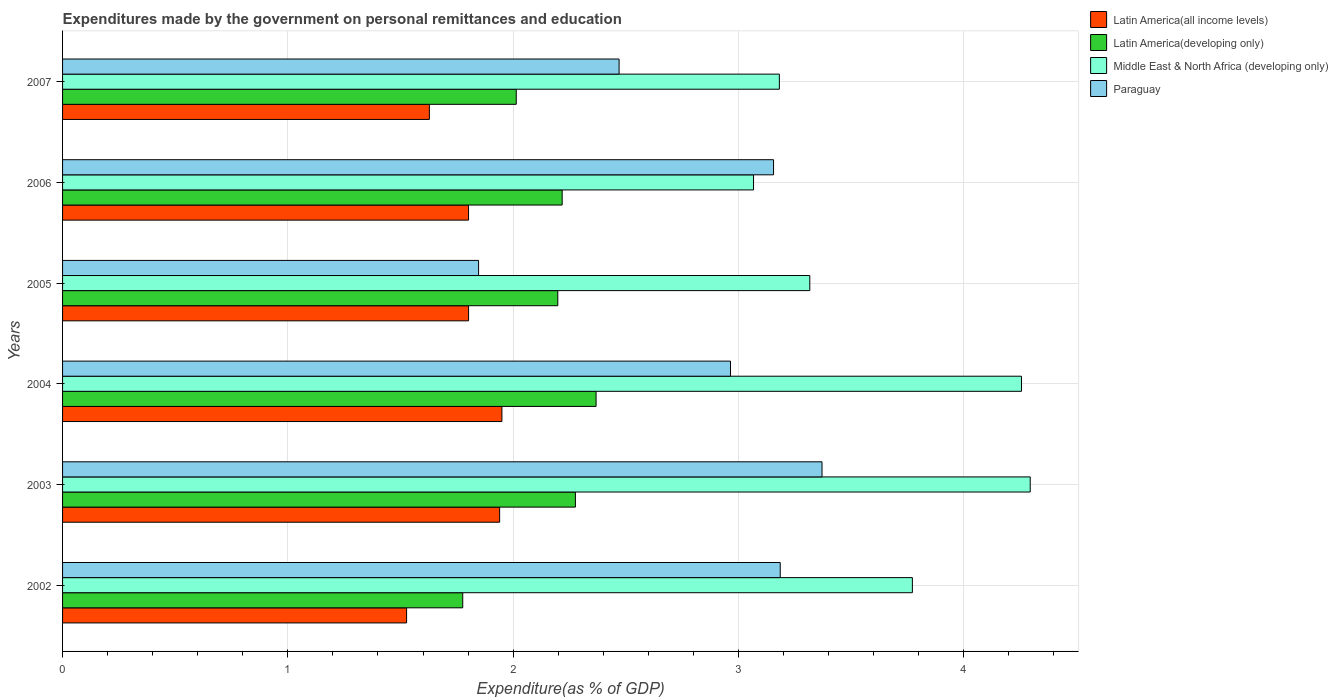Are the number of bars per tick equal to the number of legend labels?
Make the answer very short. Yes. Are the number of bars on each tick of the Y-axis equal?
Offer a very short reply. Yes. How many bars are there on the 1st tick from the top?
Provide a succinct answer. 4. What is the label of the 1st group of bars from the top?
Your answer should be very brief. 2007. What is the expenditures made by the government on personal remittances and education in Latin America(all income levels) in 2006?
Your answer should be compact. 1.8. Across all years, what is the maximum expenditures made by the government on personal remittances and education in Latin America(all income levels)?
Your answer should be very brief. 1.95. Across all years, what is the minimum expenditures made by the government on personal remittances and education in Middle East & North Africa (developing only)?
Make the answer very short. 3.07. In which year was the expenditures made by the government on personal remittances and education in Latin America(developing only) maximum?
Provide a succinct answer. 2004. What is the total expenditures made by the government on personal remittances and education in Middle East & North Africa (developing only) in the graph?
Your answer should be compact. 21.89. What is the difference between the expenditures made by the government on personal remittances and education in Middle East & North Africa (developing only) in 2005 and that in 2006?
Your response must be concise. 0.25. What is the difference between the expenditures made by the government on personal remittances and education in Paraguay in 2003 and the expenditures made by the government on personal remittances and education in Middle East & North Africa (developing only) in 2002?
Your answer should be very brief. -0.4. What is the average expenditures made by the government on personal remittances and education in Middle East & North Africa (developing only) per year?
Offer a very short reply. 3.65. In the year 2005, what is the difference between the expenditures made by the government on personal remittances and education in Latin America(all income levels) and expenditures made by the government on personal remittances and education in Latin America(developing only)?
Offer a terse response. -0.4. In how many years, is the expenditures made by the government on personal remittances and education in Latin America(developing only) greater than 0.4 %?
Keep it short and to the point. 6. What is the ratio of the expenditures made by the government on personal remittances and education in Paraguay in 2004 to that in 2005?
Provide a succinct answer. 1.61. Is the expenditures made by the government on personal remittances and education in Middle East & North Africa (developing only) in 2005 less than that in 2007?
Offer a very short reply. No. What is the difference between the highest and the second highest expenditures made by the government on personal remittances and education in Latin America(all income levels)?
Provide a succinct answer. 0.01. What is the difference between the highest and the lowest expenditures made by the government on personal remittances and education in Latin America(developing only)?
Offer a very short reply. 0.59. Is the sum of the expenditures made by the government on personal remittances and education in Latin America(all income levels) in 2003 and 2005 greater than the maximum expenditures made by the government on personal remittances and education in Middle East & North Africa (developing only) across all years?
Ensure brevity in your answer.  No. What does the 1st bar from the top in 2004 represents?
Provide a short and direct response. Paraguay. What does the 4th bar from the bottom in 2004 represents?
Keep it short and to the point. Paraguay. Is it the case that in every year, the sum of the expenditures made by the government on personal remittances and education in Middle East & North Africa (developing only) and expenditures made by the government on personal remittances and education in Latin America(developing only) is greater than the expenditures made by the government on personal remittances and education in Paraguay?
Provide a succinct answer. Yes. How many bars are there?
Your response must be concise. 24. Are all the bars in the graph horizontal?
Your answer should be compact. Yes. How many years are there in the graph?
Offer a terse response. 6. Are the values on the major ticks of X-axis written in scientific E-notation?
Offer a very short reply. No. Does the graph contain any zero values?
Your answer should be compact. No. Does the graph contain grids?
Your answer should be very brief. Yes. Where does the legend appear in the graph?
Provide a short and direct response. Top right. How many legend labels are there?
Provide a succinct answer. 4. How are the legend labels stacked?
Your response must be concise. Vertical. What is the title of the graph?
Offer a terse response. Expenditures made by the government on personal remittances and education. Does "Egypt, Arab Rep." appear as one of the legend labels in the graph?
Ensure brevity in your answer.  No. What is the label or title of the X-axis?
Keep it short and to the point. Expenditure(as % of GDP). What is the label or title of the Y-axis?
Ensure brevity in your answer.  Years. What is the Expenditure(as % of GDP) in Latin America(all income levels) in 2002?
Provide a succinct answer. 1.53. What is the Expenditure(as % of GDP) in Latin America(developing only) in 2002?
Your response must be concise. 1.78. What is the Expenditure(as % of GDP) in Middle East & North Africa (developing only) in 2002?
Offer a very short reply. 3.77. What is the Expenditure(as % of GDP) in Paraguay in 2002?
Offer a terse response. 3.19. What is the Expenditure(as % of GDP) of Latin America(all income levels) in 2003?
Your response must be concise. 1.94. What is the Expenditure(as % of GDP) in Latin America(developing only) in 2003?
Provide a short and direct response. 2.28. What is the Expenditure(as % of GDP) in Middle East & North Africa (developing only) in 2003?
Offer a very short reply. 4.3. What is the Expenditure(as % of GDP) in Paraguay in 2003?
Keep it short and to the point. 3.37. What is the Expenditure(as % of GDP) of Latin America(all income levels) in 2004?
Ensure brevity in your answer.  1.95. What is the Expenditure(as % of GDP) in Latin America(developing only) in 2004?
Give a very brief answer. 2.37. What is the Expenditure(as % of GDP) in Middle East & North Africa (developing only) in 2004?
Your response must be concise. 4.26. What is the Expenditure(as % of GDP) of Paraguay in 2004?
Your answer should be very brief. 2.96. What is the Expenditure(as % of GDP) in Latin America(all income levels) in 2005?
Your response must be concise. 1.8. What is the Expenditure(as % of GDP) of Latin America(developing only) in 2005?
Provide a short and direct response. 2.2. What is the Expenditure(as % of GDP) of Middle East & North Africa (developing only) in 2005?
Offer a very short reply. 3.32. What is the Expenditure(as % of GDP) in Paraguay in 2005?
Provide a short and direct response. 1.85. What is the Expenditure(as % of GDP) in Latin America(all income levels) in 2006?
Your answer should be very brief. 1.8. What is the Expenditure(as % of GDP) in Latin America(developing only) in 2006?
Provide a succinct answer. 2.22. What is the Expenditure(as % of GDP) in Middle East & North Africa (developing only) in 2006?
Ensure brevity in your answer.  3.07. What is the Expenditure(as % of GDP) in Paraguay in 2006?
Ensure brevity in your answer.  3.16. What is the Expenditure(as % of GDP) in Latin America(all income levels) in 2007?
Keep it short and to the point. 1.63. What is the Expenditure(as % of GDP) of Latin America(developing only) in 2007?
Provide a short and direct response. 2.01. What is the Expenditure(as % of GDP) in Middle East & North Africa (developing only) in 2007?
Give a very brief answer. 3.18. What is the Expenditure(as % of GDP) of Paraguay in 2007?
Your answer should be very brief. 2.47. Across all years, what is the maximum Expenditure(as % of GDP) in Latin America(all income levels)?
Offer a terse response. 1.95. Across all years, what is the maximum Expenditure(as % of GDP) in Latin America(developing only)?
Provide a short and direct response. 2.37. Across all years, what is the maximum Expenditure(as % of GDP) of Middle East & North Africa (developing only)?
Make the answer very short. 4.3. Across all years, what is the maximum Expenditure(as % of GDP) of Paraguay?
Offer a terse response. 3.37. Across all years, what is the minimum Expenditure(as % of GDP) in Latin America(all income levels)?
Keep it short and to the point. 1.53. Across all years, what is the minimum Expenditure(as % of GDP) in Latin America(developing only)?
Ensure brevity in your answer.  1.78. Across all years, what is the minimum Expenditure(as % of GDP) in Middle East & North Africa (developing only)?
Provide a short and direct response. 3.07. Across all years, what is the minimum Expenditure(as % of GDP) of Paraguay?
Provide a short and direct response. 1.85. What is the total Expenditure(as % of GDP) of Latin America(all income levels) in the graph?
Your answer should be compact. 10.65. What is the total Expenditure(as % of GDP) of Latin America(developing only) in the graph?
Your answer should be very brief. 12.85. What is the total Expenditure(as % of GDP) of Middle East & North Africa (developing only) in the graph?
Offer a terse response. 21.89. What is the total Expenditure(as % of GDP) of Paraguay in the graph?
Your answer should be compact. 17. What is the difference between the Expenditure(as % of GDP) in Latin America(all income levels) in 2002 and that in 2003?
Give a very brief answer. -0.41. What is the difference between the Expenditure(as % of GDP) of Latin America(developing only) in 2002 and that in 2003?
Provide a short and direct response. -0.5. What is the difference between the Expenditure(as % of GDP) of Middle East & North Africa (developing only) in 2002 and that in 2003?
Make the answer very short. -0.52. What is the difference between the Expenditure(as % of GDP) of Paraguay in 2002 and that in 2003?
Keep it short and to the point. -0.19. What is the difference between the Expenditure(as % of GDP) in Latin America(all income levels) in 2002 and that in 2004?
Provide a short and direct response. -0.42. What is the difference between the Expenditure(as % of GDP) in Latin America(developing only) in 2002 and that in 2004?
Ensure brevity in your answer.  -0.59. What is the difference between the Expenditure(as % of GDP) of Middle East & North Africa (developing only) in 2002 and that in 2004?
Your answer should be very brief. -0.48. What is the difference between the Expenditure(as % of GDP) in Paraguay in 2002 and that in 2004?
Ensure brevity in your answer.  0.22. What is the difference between the Expenditure(as % of GDP) in Latin America(all income levels) in 2002 and that in 2005?
Make the answer very short. -0.28. What is the difference between the Expenditure(as % of GDP) in Latin America(developing only) in 2002 and that in 2005?
Give a very brief answer. -0.42. What is the difference between the Expenditure(as % of GDP) in Middle East & North Africa (developing only) in 2002 and that in 2005?
Ensure brevity in your answer.  0.46. What is the difference between the Expenditure(as % of GDP) in Paraguay in 2002 and that in 2005?
Make the answer very short. 1.34. What is the difference between the Expenditure(as % of GDP) in Latin America(all income levels) in 2002 and that in 2006?
Offer a very short reply. -0.28. What is the difference between the Expenditure(as % of GDP) of Latin America(developing only) in 2002 and that in 2006?
Make the answer very short. -0.44. What is the difference between the Expenditure(as % of GDP) in Middle East & North Africa (developing only) in 2002 and that in 2006?
Provide a short and direct response. 0.71. What is the difference between the Expenditure(as % of GDP) of Paraguay in 2002 and that in 2006?
Provide a succinct answer. 0.03. What is the difference between the Expenditure(as % of GDP) of Latin America(all income levels) in 2002 and that in 2007?
Ensure brevity in your answer.  -0.1. What is the difference between the Expenditure(as % of GDP) in Latin America(developing only) in 2002 and that in 2007?
Provide a short and direct response. -0.24. What is the difference between the Expenditure(as % of GDP) of Middle East & North Africa (developing only) in 2002 and that in 2007?
Your answer should be compact. 0.59. What is the difference between the Expenditure(as % of GDP) of Paraguay in 2002 and that in 2007?
Your answer should be very brief. 0.72. What is the difference between the Expenditure(as % of GDP) of Latin America(all income levels) in 2003 and that in 2004?
Provide a short and direct response. -0.01. What is the difference between the Expenditure(as % of GDP) of Latin America(developing only) in 2003 and that in 2004?
Ensure brevity in your answer.  -0.09. What is the difference between the Expenditure(as % of GDP) of Middle East & North Africa (developing only) in 2003 and that in 2004?
Keep it short and to the point. 0.04. What is the difference between the Expenditure(as % of GDP) of Paraguay in 2003 and that in 2004?
Make the answer very short. 0.41. What is the difference between the Expenditure(as % of GDP) of Latin America(all income levels) in 2003 and that in 2005?
Offer a terse response. 0.14. What is the difference between the Expenditure(as % of GDP) in Latin America(developing only) in 2003 and that in 2005?
Offer a terse response. 0.08. What is the difference between the Expenditure(as % of GDP) of Middle East & North Africa (developing only) in 2003 and that in 2005?
Make the answer very short. 0.98. What is the difference between the Expenditure(as % of GDP) in Paraguay in 2003 and that in 2005?
Provide a short and direct response. 1.52. What is the difference between the Expenditure(as % of GDP) in Latin America(all income levels) in 2003 and that in 2006?
Provide a short and direct response. 0.14. What is the difference between the Expenditure(as % of GDP) in Latin America(developing only) in 2003 and that in 2006?
Provide a short and direct response. 0.06. What is the difference between the Expenditure(as % of GDP) of Middle East & North Africa (developing only) in 2003 and that in 2006?
Your answer should be very brief. 1.23. What is the difference between the Expenditure(as % of GDP) in Paraguay in 2003 and that in 2006?
Your answer should be compact. 0.22. What is the difference between the Expenditure(as % of GDP) of Latin America(all income levels) in 2003 and that in 2007?
Offer a very short reply. 0.31. What is the difference between the Expenditure(as % of GDP) of Latin America(developing only) in 2003 and that in 2007?
Make the answer very short. 0.26. What is the difference between the Expenditure(as % of GDP) in Middle East & North Africa (developing only) in 2003 and that in 2007?
Your response must be concise. 1.11. What is the difference between the Expenditure(as % of GDP) in Paraguay in 2003 and that in 2007?
Keep it short and to the point. 0.9. What is the difference between the Expenditure(as % of GDP) in Latin America(all income levels) in 2004 and that in 2005?
Provide a succinct answer. 0.15. What is the difference between the Expenditure(as % of GDP) in Latin America(developing only) in 2004 and that in 2005?
Offer a very short reply. 0.17. What is the difference between the Expenditure(as % of GDP) in Middle East & North Africa (developing only) in 2004 and that in 2005?
Offer a very short reply. 0.94. What is the difference between the Expenditure(as % of GDP) in Paraguay in 2004 and that in 2005?
Your answer should be compact. 1.12. What is the difference between the Expenditure(as % of GDP) in Latin America(all income levels) in 2004 and that in 2006?
Provide a succinct answer. 0.15. What is the difference between the Expenditure(as % of GDP) of Latin America(developing only) in 2004 and that in 2006?
Your answer should be compact. 0.15. What is the difference between the Expenditure(as % of GDP) in Middle East & North Africa (developing only) in 2004 and that in 2006?
Make the answer very short. 1.19. What is the difference between the Expenditure(as % of GDP) in Paraguay in 2004 and that in 2006?
Give a very brief answer. -0.19. What is the difference between the Expenditure(as % of GDP) of Latin America(all income levels) in 2004 and that in 2007?
Give a very brief answer. 0.32. What is the difference between the Expenditure(as % of GDP) in Latin America(developing only) in 2004 and that in 2007?
Your answer should be compact. 0.35. What is the difference between the Expenditure(as % of GDP) in Middle East & North Africa (developing only) in 2004 and that in 2007?
Offer a very short reply. 1.07. What is the difference between the Expenditure(as % of GDP) of Paraguay in 2004 and that in 2007?
Offer a terse response. 0.49. What is the difference between the Expenditure(as % of GDP) in Latin America(developing only) in 2005 and that in 2006?
Offer a very short reply. -0.02. What is the difference between the Expenditure(as % of GDP) in Middle East & North Africa (developing only) in 2005 and that in 2006?
Give a very brief answer. 0.25. What is the difference between the Expenditure(as % of GDP) in Paraguay in 2005 and that in 2006?
Make the answer very short. -1.31. What is the difference between the Expenditure(as % of GDP) in Latin America(all income levels) in 2005 and that in 2007?
Ensure brevity in your answer.  0.17. What is the difference between the Expenditure(as % of GDP) of Latin America(developing only) in 2005 and that in 2007?
Offer a very short reply. 0.18. What is the difference between the Expenditure(as % of GDP) in Middle East & North Africa (developing only) in 2005 and that in 2007?
Give a very brief answer. 0.14. What is the difference between the Expenditure(as % of GDP) of Paraguay in 2005 and that in 2007?
Make the answer very short. -0.62. What is the difference between the Expenditure(as % of GDP) of Latin America(all income levels) in 2006 and that in 2007?
Provide a short and direct response. 0.17. What is the difference between the Expenditure(as % of GDP) in Latin America(developing only) in 2006 and that in 2007?
Provide a short and direct response. 0.2. What is the difference between the Expenditure(as % of GDP) in Middle East & North Africa (developing only) in 2006 and that in 2007?
Offer a terse response. -0.11. What is the difference between the Expenditure(as % of GDP) of Paraguay in 2006 and that in 2007?
Your answer should be very brief. 0.69. What is the difference between the Expenditure(as % of GDP) in Latin America(all income levels) in 2002 and the Expenditure(as % of GDP) in Latin America(developing only) in 2003?
Make the answer very short. -0.75. What is the difference between the Expenditure(as % of GDP) of Latin America(all income levels) in 2002 and the Expenditure(as % of GDP) of Middle East & North Africa (developing only) in 2003?
Ensure brevity in your answer.  -2.77. What is the difference between the Expenditure(as % of GDP) of Latin America(all income levels) in 2002 and the Expenditure(as % of GDP) of Paraguay in 2003?
Your response must be concise. -1.84. What is the difference between the Expenditure(as % of GDP) in Latin America(developing only) in 2002 and the Expenditure(as % of GDP) in Middle East & North Africa (developing only) in 2003?
Provide a short and direct response. -2.52. What is the difference between the Expenditure(as % of GDP) in Latin America(developing only) in 2002 and the Expenditure(as % of GDP) in Paraguay in 2003?
Offer a very short reply. -1.59. What is the difference between the Expenditure(as % of GDP) of Middle East & North Africa (developing only) in 2002 and the Expenditure(as % of GDP) of Paraguay in 2003?
Ensure brevity in your answer.  0.4. What is the difference between the Expenditure(as % of GDP) of Latin America(all income levels) in 2002 and the Expenditure(as % of GDP) of Latin America(developing only) in 2004?
Offer a terse response. -0.84. What is the difference between the Expenditure(as % of GDP) of Latin America(all income levels) in 2002 and the Expenditure(as % of GDP) of Middle East & North Africa (developing only) in 2004?
Keep it short and to the point. -2.73. What is the difference between the Expenditure(as % of GDP) of Latin America(all income levels) in 2002 and the Expenditure(as % of GDP) of Paraguay in 2004?
Give a very brief answer. -1.44. What is the difference between the Expenditure(as % of GDP) in Latin America(developing only) in 2002 and the Expenditure(as % of GDP) in Middle East & North Africa (developing only) in 2004?
Provide a succinct answer. -2.48. What is the difference between the Expenditure(as % of GDP) in Latin America(developing only) in 2002 and the Expenditure(as % of GDP) in Paraguay in 2004?
Ensure brevity in your answer.  -1.19. What is the difference between the Expenditure(as % of GDP) of Middle East & North Africa (developing only) in 2002 and the Expenditure(as % of GDP) of Paraguay in 2004?
Keep it short and to the point. 0.81. What is the difference between the Expenditure(as % of GDP) in Latin America(all income levels) in 2002 and the Expenditure(as % of GDP) in Latin America(developing only) in 2005?
Offer a terse response. -0.67. What is the difference between the Expenditure(as % of GDP) of Latin America(all income levels) in 2002 and the Expenditure(as % of GDP) of Middle East & North Africa (developing only) in 2005?
Provide a succinct answer. -1.79. What is the difference between the Expenditure(as % of GDP) of Latin America(all income levels) in 2002 and the Expenditure(as % of GDP) of Paraguay in 2005?
Ensure brevity in your answer.  -0.32. What is the difference between the Expenditure(as % of GDP) of Latin America(developing only) in 2002 and the Expenditure(as % of GDP) of Middle East & North Africa (developing only) in 2005?
Your answer should be very brief. -1.54. What is the difference between the Expenditure(as % of GDP) in Latin America(developing only) in 2002 and the Expenditure(as % of GDP) in Paraguay in 2005?
Your answer should be very brief. -0.07. What is the difference between the Expenditure(as % of GDP) of Middle East & North Africa (developing only) in 2002 and the Expenditure(as % of GDP) of Paraguay in 2005?
Your response must be concise. 1.93. What is the difference between the Expenditure(as % of GDP) in Latin America(all income levels) in 2002 and the Expenditure(as % of GDP) in Latin America(developing only) in 2006?
Provide a succinct answer. -0.69. What is the difference between the Expenditure(as % of GDP) of Latin America(all income levels) in 2002 and the Expenditure(as % of GDP) of Middle East & North Africa (developing only) in 2006?
Give a very brief answer. -1.54. What is the difference between the Expenditure(as % of GDP) in Latin America(all income levels) in 2002 and the Expenditure(as % of GDP) in Paraguay in 2006?
Keep it short and to the point. -1.63. What is the difference between the Expenditure(as % of GDP) of Latin America(developing only) in 2002 and the Expenditure(as % of GDP) of Middle East & North Africa (developing only) in 2006?
Ensure brevity in your answer.  -1.29. What is the difference between the Expenditure(as % of GDP) of Latin America(developing only) in 2002 and the Expenditure(as % of GDP) of Paraguay in 2006?
Your answer should be compact. -1.38. What is the difference between the Expenditure(as % of GDP) of Middle East & North Africa (developing only) in 2002 and the Expenditure(as % of GDP) of Paraguay in 2006?
Keep it short and to the point. 0.62. What is the difference between the Expenditure(as % of GDP) of Latin America(all income levels) in 2002 and the Expenditure(as % of GDP) of Latin America(developing only) in 2007?
Ensure brevity in your answer.  -0.49. What is the difference between the Expenditure(as % of GDP) in Latin America(all income levels) in 2002 and the Expenditure(as % of GDP) in Middle East & North Africa (developing only) in 2007?
Keep it short and to the point. -1.65. What is the difference between the Expenditure(as % of GDP) of Latin America(all income levels) in 2002 and the Expenditure(as % of GDP) of Paraguay in 2007?
Make the answer very short. -0.94. What is the difference between the Expenditure(as % of GDP) in Latin America(developing only) in 2002 and the Expenditure(as % of GDP) in Middle East & North Africa (developing only) in 2007?
Ensure brevity in your answer.  -1.41. What is the difference between the Expenditure(as % of GDP) in Latin America(developing only) in 2002 and the Expenditure(as % of GDP) in Paraguay in 2007?
Provide a succinct answer. -0.69. What is the difference between the Expenditure(as % of GDP) of Middle East & North Africa (developing only) in 2002 and the Expenditure(as % of GDP) of Paraguay in 2007?
Offer a terse response. 1.3. What is the difference between the Expenditure(as % of GDP) in Latin America(all income levels) in 2003 and the Expenditure(as % of GDP) in Latin America(developing only) in 2004?
Your answer should be very brief. -0.43. What is the difference between the Expenditure(as % of GDP) of Latin America(all income levels) in 2003 and the Expenditure(as % of GDP) of Middle East & North Africa (developing only) in 2004?
Keep it short and to the point. -2.32. What is the difference between the Expenditure(as % of GDP) of Latin America(all income levels) in 2003 and the Expenditure(as % of GDP) of Paraguay in 2004?
Your answer should be compact. -1.02. What is the difference between the Expenditure(as % of GDP) of Latin America(developing only) in 2003 and the Expenditure(as % of GDP) of Middle East & North Africa (developing only) in 2004?
Offer a terse response. -1.98. What is the difference between the Expenditure(as % of GDP) of Latin America(developing only) in 2003 and the Expenditure(as % of GDP) of Paraguay in 2004?
Your answer should be compact. -0.69. What is the difference between the Expenditure(as % of GDP) in Middle East & North Africa (developing only) in 2003 and the Expenditure(as % of GDP) in Paraguay in 2004?
Offer a terse response. 1.33. What is the difference between the Expenditure(as % of GDP) of Latin America(all income levels) in 2003 and the Expenditure(as % of GDP) of Latin America(developing only) in 2005?
Ensure brevity in your answer.  -0.26. What is the difference between the Expenditure(as % of GDP) of Latin America(all income levels) in 2003 and the Expenditure(as % of GDP) of Middle East & North Africa (developing only) in 2005?
Offer a terse response. -1.38. What is the difference between the Expenditure(as % of GDP) in Latin America(all income levels) in 2003 and the Expenditure(as % of GDP) in Paraguay in 2005?
Your response must be concise. 0.09. What is the difference between the Expenditure(as % of GDP) in Latin America(developing only) in 2003 and the Expenditure(as % of GDP) in Middle East & North Africa (developing only) in 2005?
Your response must be concise. -1.04. What is the difference between the Expenditure(as % of GDP) in Latin America(developing only) in 2003 and the Expenditure(as % of GDP) in Paraguay in 2005?
Your response must be concise. 0.43. What is the difference between the Expenditure(as % of GDP) of Middle East & North Africa (developing only) in 2003 and the Expenditure(as % of GDP) of Paraguay in 2005?
Provide a succinct answer. 2.45. What is the difference between the Expenditure(as % of GDP) of Latin America(all income levels) in 2003 and the Expenditure(as % of GDP) of Latin America(developing only) in 2006?
Your answer should be very brief. -0.28. What is the difference between the Expenditure(as % of GDP) of Latin America(all income levels) in 2003 and the Expenditure(as % of GDP) of Middle East & North Africa (developing only) in 2006?
Provide a succinct answer. -1.13. What is the difference between the Expenditure(as % of GDP) of Latin America(all income levels) in 2003 and the Expenditure(as % of GDP) of Paraguay in 2006?
Keep it short and to the point. -1.22. What is the difference between the Expenditure(as % of GDP) of Latin America(developing only) in 2003 and the Expenditure(as % of GDP) of Middle East & North Africa (developing only) in 2006?
Your response must be concise. -0.79. What is the difference between the Expenditure(as % of GDP) in Latin America(developing only) in 2003 and the Expenditure(as % of GDP) in Paraguay in 2006?
Offer a very short reply. -0.88. What is the difference between the Expenditure(as % of GDP) in Middle East & North Africa (developing only) in 2003 and the Expenditure(as % of GDP) in Paraguay in 2006?
Make the answer very short. 1.14. What is the difference between the Expenditure(as % of GDP) of Latin America(all income levels) in 2003 and the Expenditure(as % of GDP) of Latin America(developing only) in 2007?
Your response must be concise. -0.07. What is the difference between the Expenditure(as % of GDP) in Latin America(all income levels) in 2003 and the Expenditure(as % of GDP) in Middle East & North Africa (developing only) in 2007?
Ensure brevity in your answer.  -1.24. What is the difference between the Expenditure(as % of GDP) of Latin America(all income levels) in 2003 and the Expenditure(as % of GDP) of Paraguay in 2007?
Provide a short and direct response. -0.53. What is the difference between the Expenditure(as % of GDP) of Latin America(developing only) in 2003 and the Expenditure(as % of GDP) of Middle East & North Africa (developing only) in 2007?
Your answer should be very brief. -0.91. What is the difference between the Expenditure(as % of GDP) in Latin America(developing only) in 2003 and the Expenditure(as % of GDP) in Paraguay in 2007?
Ensure brevity in your answer.  -0.19. What is the difference between the Expenditure(as % of GDP) of Middle East & North Africa (developing only) in 2003 and the Expenditure(as % of GDP) of Paraguay in 2007?
Keep it short and to the point. 1.82. What is the difference between the Expenditure(as % of GDP) of Latin America(all income levels) in 2004 and the Expenditure(as % of GDP) of Latin America(developing only) in 2005?
Provide a short and direct response. -0.25. What is the difference between the Expenditure(as % of GDP) of Latin America(all income levels) in 2004 and the Expenditure(as % of GDP) of Middle East & North Africa (developing only) in 2005?
Offer a very short reply. -1.37. What is the difference between the Expenditure(as % of GDP) of Latin America(all income levels) in 2004 and the Expenditure(as % of GDP) of Paraguay in 2005?
Offer a very short reply. 0.1. What is the difference between the Expenditure(as % of GDP) of Latin America(developing only) in 2004 and the Expenditure(as % of GDP) of Middle East & North Africa (developing only) in 2005?
Ensure brevity in your answer.  -0.95. What is the difference between the Expenditure(as % of GDP) of Latin America(developing only) in 2004 and the Expenditure(as % of GDP) of Paraguay in 2005?
Offer a very short reply. 0.52. What is the difference between the Expenditure(as % of GDP) in Middle East & North Africa (developing only) in 2004 and the Expenditure(as % of GDP) in Paraguay in 2005?
Provide a succinct answer. 2.41. What is the difference between the Expenditure(as % of GDP) of Latin America(all income levels) in 2004 and the Expenditure(as % of GDP) of Latin America(developing only) in 2006?
Provide a succinct answer. -0.27. What is the difference between the Expenditure(as % of GDP) of Latin America(all income levels) in 2004 and the Expenditure(as % of GDP) of Middle East & North Africa (developing only) in 2006?
Your response must be concise. -1.12. What is the difference between the Expenditure(as % of GDP) in Latin America(all income levels) in 2004 and the Expenditure(as % of GDP) in Paraguay in 2006?
Your answer should be compact. -1.21. What is the difference between the Expenditure(as % of GDP) in Latin America(developing only) in 2004 and the Expenditure(as % of GDP) in Middle East & North Africa (developing only) in 2006?
Provide a succinct answer. -0.7. What is the difference between the Expenditure(as % of GDP) in Latin America(developing only) in 2004 and the Expenditure(as % of GDP) in Paraguay in 2006?
Make the answer very short. -0.79. What is the difference between the Expenditure(as % of GDP) in Middle East & North Africa (developing only) in 2004 and the Expenditure(as % of GDP) in Paraguay in 2006?
Ensure brevity in your answer.  1.1. What is the difference between the Expenditure(as % of GDP) of Latin America(all income levels) in 2004 and the Expenditure(as % of GDP) of Latin America(developing only) in 2007?
Make the answer very short. -0.06. What is the difference between the Expenditure(as % of GDP) in Latin America(all income levels) in 2004 and the Expenditure(as % of GDP) in Middle East & North Africa (developing only) in 2007?
Keep it short and to the point. -1.23. What is the difference between the Expenditure(as % of GDP) of Latin America(all income levels) in 2004 and the Expenditure(as % of GDP) of Paraguay in 2007?
Your answer should be very brief. -0.52. What is the difference between the Expenditure(as % of GDP) of Latin America(developing only) in 2004 and the Expenditure(as % of GDP) of Middle East & North Africa (developing only) in 2007?
Your response must be concise. -0.81. What is the difference between the Expenditure(as % of GDP) in Latin America(developing only) in 2004 and the Expenditure(as % of GDP) in Paraguay in 2007?
Ensure brevity in your answer.  -0.1. What is the difference between the Expenditure(as % of GDP) of Middle East & North Africa (developing only) in 2004 and the Expenditure(as % of GDP) of Paraguay in 2007?
Ensure brevity in your answer.  1.79. What is the difference between the Expenditure(as % of GDP) of Latin America(all income levels) in 2005 and the Expenditure(as % of GDP) of Latin America(developing only) in 2006?
Offer a very short reply. -0.42. What is the difference between the Expenditure(as % of GDP) in Latin America(all income levels) in 2005 and the Expenditure(as % of GDP) in Middle East & North Africa (developing only) in 2006?
Offer a terse response. -1.26. What is the difference between the Expenditure(as % of GDP) of Latin America(all income levels) in 2005 and the Expenditure(as % of GDP) of Paraguay in 2006?
Your response must be concise. -1.35. What is the difference between the Expenditure(as % of GDP) in Latin America(developing only) in 2005 and the Expenditure(as % of GDP) in Middle East & North Africa (developing only) in 2006?
Provide a short and direct response. -0.87. What is the difference between the Expenditure(as % of GDP) in Latin America(developing only) in 2005 and the Expenditure(as % of GDP) in Paraguay in 2006?
Ensure brevity in your answer.  -0.96. What is the difference between the Expenditure(as % of GDP) of Middle East & North Africa (developing only) in 2005 and the Expenditure(as % of GDP) of Paraguay in 2006?
Your answer should be compact. 0.16. What is the difference between the Expenditure(as % of GDP) of Latin America(all income levels) in 2005 and the Expenditure(as % of GDP) of Latin America(developing only) in 2007?
Make the answer very short. -0.21. What is the difference between the Expenditure(as % of GDP) of Latin America(all income levels) in 2005 and the Expenditure(as % of GDP) of Middle East & North Africa (developing only) in 2007?
Provide a succinct answer. -1.38. What is the difference between the Expenditure(as % of GDP) in Latin America(all income levels) in 2005 and the Expenditure(as % of GDP) in Paraguay in 2007?
Make the answer very short. -0.67. What is the difference between the Expenditure(as % of GDP) of Latin America(developing only) in 2005 and the Expenditure(as % of GDP) of Middle East & North Africa (developing only) in 2007?
Ensure brevity in your answer.  -0.98. What is the difference between the Expenditure(as % of GDP) of Latin America(developing only) in 2005 and the Expenditure(as % of GDP) of Paraguay in 2007?
Give a very brief answer. -0.27. What is the difference between the Expenditure(as % of GDP) in Middle East & North Africa (developing only) in 2005 and the Expenditure(as % of GDP) in Paraguay in 2007?
Offer a very short reply. 0.85. What is the difference between the Expenditure(as % of GDP) of Latin America(all income levels) in 2006 and the Expenditure(as % of GDP) of Latin America(developing only) in 2007?
Ensure brevity in your answer.  -0.21. What is the difference between the Expenditure(as % of GDP) in Latin America(all income levels) in 2006 and the Expenditure(as % of GDP) in Middle East & North Africa (developing only) in 2007?
Offer a very short reply. -1.38. What is the difference between the Expenditure(as % of GDP) in Latin America(all income levels) in 2006 and the Expenditure(as % of GDP) in Paraguay in 2007?
Your response must be concise. -0.67. What is the difference between the Expenditure(as % of GDP) in Latin America(developing only) in 2006 and the Expenditure(as % of GDP) in Middle East & North Africa (developing only) in 2007?
Ensure brevity in your answer.  -0.96. What is the difference between the Expenditure(as % of GDP) in Latin America(developing only) in 2006 and the Expenditure(as % of GDP) in Paraguay in 2007?
Give a very brief answer. -0.25. What is the difference between the Expenditure(as % of GDP) of Middle East & North Africa (developing only) in 2006 and the Expenditure(as % of GDP) of Paraguay in 2007?
Offer a terse response. 0.6. What is the average Expenditure(as % of GDP) in Latin America(all income levels) per year?
Give a very brief answer. 1.77. What is the average Expenditure(as % of GDP) of Latin America(developing only) per year?
Provide a short and direct response. 2.14. What is the average Expenditure(as % of GDP) in Middle East & North Africa (developing only) per year?
Your response must be concise. 3.65. What is the average Expenditure(as % of GDP) in Paraguay per year?
Your response must be concise. 2.83. In the year 2002, what is the difference between the Expenditure(as % of GDP) in Latin America(all income levels) and Expenditure(as % of GDP) in Latin America(developing only)?
Offer a very short reply. -0.25. In the year 2002, what is the difference between the Expenditure(as % of GDP) in Latin America(all income levels) and Expenditure(as % of GDP) in Middle East & North Africa (developing only)?
Make the answer very short. -2.25. In the year 2002, what is the difference between the Expenditure(as % of GDP) of Latin America(all income levels) and Expenditure(as % of GDP) of Paraguay?
Provide a short and direct response. -1.66. In the year 2002, what is the difference between the Expenditure(as % of GDP) of Latin America(developing only) and Expenditure(as % of GDP) of Middle East & North Africa (developing only)?
Give a very brief answer. -2. In the year 2002, what is the difference between the Expenditure(as % of GDP) in Latin America(developing only) and Expenditure(as % of GDP) in Paraguay?
Ensure brevity in your answer.  -1.41. In the year 2002, what is the difference between the Expenditure(as % of GDP) of Middle East & North Africa (developing only) and Expenditure(as % of GDP) of Paraguay?
Provide a short and direct response. 0.59. In the year 2003, what is the difference between the Expenditure(as % of GDP) of Latin America(all income levels) and Expenditure(as % of GDP) of Latin America(developing only)?
Make the answer very short. -0.34. In the year 2003, what is the difference between the Expenditure(as % of GDP) of Latin America(all income levels) and Expenditure(as % of GDP) of Middle East & North Africa (developing only)?
Your answer should be compact. -2.36. In the year 2003, what is the difference between the Expenditure(as % of GDP) of Latin America(all income levels) and Expenditure(as % of GDP) of Paraguay?
Your answer should be very brief. -1.43. In the year 2003, what is the difference between the Expenditure(as % of GDP) in Latin America(developing only) and Expenditure(as % of GDP) in Middle East & North Africa (developing only)?
Keep it short and to the point. -2.02. In the year 2003, what is the difference between the Expenditure(as % of GDP) of Latin America(developing only) and Expenditure(as % of GDP) of Paraguay?
Give a very brief answer. -1.09. In the year 2003, what is the difference between the Expenditure(as % of GDP) in Middle East & North Africa (developing only) and Expenditure(as % of GDP) in Paraguay?
Offer a terse response. 0.92. In the year 2004, what is the difference between the Expenditure(as % of GDP) of Latin America(all income levels) and Expenditure(as % of GDP) of Latin America(developing only)?
Your answer should be very brief. -0.42. In the year 2004, what is the difference between the Expenditure(as % of GDP) in Latin America(all income levels) and Expenditure(as % of GDP) in Middle East & North Africa (developing only)?
Offer a terse response. -2.31. In the year 2004, what is the difference between the Expenditure(as % of GDP) of Latin America(all income levels) and Expenditure(as % of GDP) of Paraguay?
Ensure brevity in your answer.  -1.01. In the year 2004, what is the difference between the Expenditure(as % of GDP) of Latin America(developing only) and Expenditure(as % of GDP) of Middle East & North Africa (developing only)?
Your answer should be very brief. -1.89. In the year 2004, what is the difference between the Expenditure(as % of GDP) of Latin America(developing only) and Expenditure(as % of GDP) of Paraguay?
Offer a terse response. -0.6. In the year 2004, what is the difference between the Expenditure(as % of GDP) of Middle East & North Africa (developing only) and Expenditure(as % of GDP) of Paraguay?
Offer a very short reply. 1.29. In the year 2005, what is the difference between the Expenditure(as % of GDP) of Latin America(all income levels) and Expenditure(as % of GDP) of Latin America(developing only)?
Your answer should be compact. -0.4. In the year 2005, what is the difference between the Expenditure(as % of GDP) of Latin America(all income levels) and Expenditure(as % of GDP) of Middle East & North Africa (developing only)?
Provide a succinct answer. -1.51. In the year 2005, what is the difference between the Expenditure(as % of GDP) of Latin America(all income levels) and Expenditure(as % of GDP) of Paraguay?
Offer a terse response. -0.04. In the year 2005, what is the difference between the Expenditure(as % of GDP) of Latin America(developing only) and Expenditure(as % of GDP) of Middle East & North Africa (developing only)?
Offer a very short reply. -1.12. In the year 2005, what is the difference between the Expenditure(as % of GDP) of Latin America(developing only) and Expenditure(as % of GDP) of Paraguay?
Make the answer very short. 0.35. In the year 2005, what is the difference between the Expenditure(as % of GDP) in Middle East & North Africa (developing only) and Expenditure(as % of GDP) in Paraguay?
Your response must be concise. 1.47. In the year 2006, what is the difference between the Expenditure(as % of GDP) of Latin America(all income levels) and Expenditure(as % of GDP) of Latin America(developing only)?
Ensure brevity in your answer.  -0.42. In the year 2006, what is the difference between the Expenditure(as % of GDP) in Latin America(all income levels) and Expenditure(as % of GDP) in Middle East & North Africa (developing only)?
Ensure brevity in your answer.  -1.26. In the year 2006, what is the difference between the Expenditure(as % of GDP) of Latin America(all income levels) and Expenditure(as % of GDP) of Paraguay?
Give a very brief answer. -1.35. In the year 2006, what is the difference between the Expenditure(as % of GDP) of Latin America(developing only) and Expenditure(as % of GDP) of Middle East & North Africa (developing only)?
Your answer should be compact. -0.85. In the year 2006, what is the difference between the Expenditure(as % of GDP) in Latin America(developing only) and Expenditure(as % of GDP) in Paraguay?
Give a very brief answer. -0.94. In the year 2006, what is the difference between the Expenditure(as % of GDP) in Middle East & North Africa (developing only) and Expenditure(as % of GDP) in Paraguay?
Your response must be concise. -0.09. In the year 2007, what is the difference between the Expenditure(as % of GDP) of Latin America(all income levels) and Expenditure(as % of GDP) of Latin America(developing only)?
Your response must be concise. -0.39. In the year 2007, what is the difference between the Expenditure(as % of GDP) in Latin America(all income levels) and Expenditure(as % of GDP) in Middle East & North Africa (developing only)?
Keep it short and to the point. -1.55. In the year 2007, what is the difference between the Expenditure(as % of GDP) in Latin America(all income levels) and Expenditure(as % of GDP) in Paraguay?
Offer a terse response. -0.84. In the year 2007, what is the difference between the Expenditure(as % of GDP) in Latin America(developing only) and Expenditure(as % of GDP) in Middle East & North Africa (developing only)?
Your answer should be compact. -1.17. In the year 2007, what is the difference between the Expenditure(as % of GDP) of Latin America(developing only) and Expenditure(as % of GDP) of Paraguay?
Offer a terse response. -0.46. In the year 2007, what is the difference between the Expenditure(as % of GDP) of Middle East & North Africa (developing only) and Expenditure(as % of GDP) of Paraguay?
Ensure brevity in your answer.  0.71. What is the ratio of the Expenditure(as % of GDP) of Latin America(all income levels) in 2002 to that in 2003?
Offer a terse response. 0.79. What is the ratio of the Expenditure(as % of GDP) of Latin America(developing only) in 2002 to that in 2003?
Offer a terse response. 0.78. What is the ratio of the Expenditure(as % of GDP) in Middle East & North Africa (developing only) in 2002 to that in 2003?
Your response must be concise. 0.88. What is the ratio of the Expenditure(as % of GDP) in Paraguay in 2002 to that in 2003?
Offer a very short reply. 0.94. What is the ratio of the Expenditure(as % of GDP) in Latin America(all income levels) in 2002 to that in 2004?
Ensure brevity in your answer.  0.78. What is the ratio of the Expenditure(as % of GDP) of Middle East & North Africa (developing only) in 2002 to that in 2004?
Offer a very short reply. 0.89. What is the ratio of the Expenditure(as % of GDP) of Paraguay in 2002 to that in 2004?
Ensure brevity in your answer.  1.07. What is the ratio of the Expenditure(as % of GDP) in Latin America(all income levels) in 2002 to that in 2005?
Keep it short and to the point. 0.85. What is the ratio of the Expenditure(as % of GDP) in Latin America(developing only) in 2002 to that in 2005?
Offer a very short reply. 0.81. What is the ratio of the Expenditure(as % of GDP) in Middle East & North Africa (developing only) in 2002 to that in 2005?
Give a very brief answer. 1.14. What is the ratio of the Expenditure(as % of GDP) of Paraguay in 2002 to that in 2005?
Make the answer very short. 1.73. What is the ratio of the Expenditure(as % of GDP) in Latin America(all income levels) in 2002 to that in 2006?
Provide a succinct answer. 0.85. What is the ratio of the Expenditure(as % of GDP) in Latin America(developing only) in 2002 to that in 2006?
Give a very brief answer. 0.8. What is the ratio of the Expenditure(as % of GDP) of Middle East & North Africa (developing only) in 2002 to that in 2006?
Keep it short and to the point. 1.23. What is the ratio of the Expenditure(as % of GDP) of Paraguay in 2002 to that in 2006?
Your response must be concise. 1.01. What is the ratio of the Expenditure(as % of GDP) in Latin America(all income levels) in 2002 to that in 2007?
Provide a short and direct response. 0.94. What is the ratio of the Expenditure(as % of GDP) in Latin America(developing only) in 2002 to that in 2007?
Provide a short and direct response. 0.88. What is the ratio of the Expenditure(as % of GDP) of Middle East & North Africa (developing only) in 2002 to that in 2007?
Offer a terse response. 1.19. What is the ratio of the Expenditure(as % of GDP) of Paraguay in 2002 to that in 2007?
Make the answer very short. 1.29. What is the ratio of the Expenditure(as % of GDP) in Latin America(developing only) in 2003 to that in 2004?
Make the answer very short. 0.96. What is the ratio of the Expenditure(as % of GDP) in Middle East & North Africa (developing only) in 2003 to that in 2004?
Your answer should be compact. 1.01. What is the ratio of the Expenditure(as % of GDP) of Paraguay in 2003 to that in 2004?
Your answer should be compact. 1.14. What is the ratio of the Expenditure(as % of GDP) of Latin America(all income levels) in 2003 to that in 2005?
Ensure brevity in your answer.  1.08. What is the ratio of the Expenditure(as % of GDP) of Latin America(developing only) in 2003 to that in 2005?
Ensure brevity in your answer.  1.04. What is the ratio of the Expenditure(as % of GDP) in Middle East & North Africa (developing only) in 2003 to that in 2005?
Provide a short and direct response. 1.29. What is the ratio of the Expenditure(as % of GDP) of Paraguay in 2003 to that in 2005?
Offer a very short reply. 1.83. What is the ratio of the Expenditure(as % of GDP) of Latin America(all income levels) in 2003 to that in 2006?
Your response must be concise. 1.08. What is the ratio of the Expenditure(as % of GDP) of Latin America(developing only) in 2003 to that in 2006?
Your answer should be very brief. 1.03. What is the ratio of the Expenditure(as % of GDP) in Middle East & North Africa (developing only) in 2003 to that in 2006?
Ensure brevity in your answer.  1.4. What is the ratio of the Expenditure(as % of GDP) in Paraguay in 2003 to that in 2006?
Your answer should be compact. 1.07. What is the ratio of the Expenditure(as % of GDP) of Latin America(all income levels) in 2003 to that in 2007?
Make the answer very short. 1.19. What is the ratio of the Expenditure(as % of GDP) of Latin America(developing only) in 2003 to that in 2007?
Provide a short and direct response. 1.13. What is the ratio of the Expenditure(as % of GDP) in Middle East & North Africa (developing only) in 2003 to that in 2007?
Provide a short and direct response. 1.35. What is the ratio of the Expenditure(as % of GDP) in Paraguay in 2003 to that in 2007?
Provide a short and direct response. 1.36. What is the ratio of the Expenditure(as % of GDP) of Latin America(all income levels) in 2004 to that in 2005?
Provide a succinct answer. 1.08. What is the ratio of the Expenditure(as % of GDP) in Latin America(developing only) in 2004 to that in 2005?
Ensure brevity in your answer.  1.08. What is the ratio of the Expenditure(as % of GDP) in Middle East & North Africa (developing only) in 2004 to that in 2005?
Provide a short and direct response. 1.28. What is the ratio of the Expenditure(as % of GDP) in Paraguay in 2004 to that in 2005?
Make the answer very short. 1.61. What is the ratio of the Expenditure(as % of GDP) in Latin America(all income levels) in 2004 to that in 2006?
Ensure brevity in your answer.  1.08. What is the ratio of the Expenditure(as % of GDP) in Latin America(developing only) in 2004 to that in 2006?
Offer a terse response. 1.07. What is the ratio of the Expenditure(as % of GDP) in Middle East & North Africa (developing only) in 2004 to that in 2006?
Keep it short and to the point. 1.39. What is the ratio of the Expenditure(as % of GDP) in Paraguay in 2004 to that in 2006?
Provide a short and direct response. 0.94. What is the ratio of the Expenditure(as % of GDP) of Latin America(all income levels) in 2004 to that in 2007?
Your answer should be very brief. 1.2. What is the ratio of the Expenditure(as % of GDP) in Latin America(developing only) in 2004 to that in 2007?
Keep it short and to the point. 1.18. What is the ratio of the Expenditure(as % of GDP) of Middle East & North Africa (developing only) in 2004 to that in 2007?
Give a very brief answer. 1.34. What is the ratio of the Expenditure(as % of GDP) in Paraguay in 2004 to that in 2007?
Keep it short and to the point. 1.2. What is the ratio of the Expenditure(as % of GDP) of Latin America(all income levels) in 2005 to that in 2006?
Provide a short and direct response. 1. What is the ratio of the Expenditure(as % of GDP) of Middle East & North Africa (developing only) in 2005 to that in 2006?
Ensure brevity in your answer.  1.08. What is the ratio of the Expenditure(as % of GDP) of Paraguay in 2005 to that in 2006?
Your answer should be very brief. 0.59. What is the ratio of the Expenditure(as % of GDP) of Latin America(all income levels) in 2005 to that in 2007?
Provide a succinct answer. 1.11. What is the ratio of the Expenditure(as % of GDP) in Latin America(developing only) in 2005 to that in 2007?
Your response must be concise. 1.09. What is the ratio of the Expenditure(as % of GDP) in Middle East & North Africa (developing only) in 2005 to that in 2007?
Your response must be concise. 1.04. What is the ratio of the Expenditure(as % of GDP) in Paraguay in 2005 to that in 2007?
Provide a succinct answer. 0.75. What is the ratio of the Expenditure(as % of GDP) in Latin America(all income levels) in 2006 to that in 2007?
Ensure brevity in your answer.  1.11. What is the ratio of the Expenditure(as % of GDP) in Latin America(developing only) in 2006 to that in 2007?
Offer a terse response. 1.1. What is the ratio of the Expenditure(as % of GDP) in Paraguay in 2006 to that in 2007?
Make the answer very short. 1.28. What is the difference between the highest and the second highest Expenditure(as % of GDP) of Latin America(all income levels)?
Your answer should be compact. 0.01. What is the difference between the highest and the second highest Expenditure(as % of GDP) in Latin America(developing only)?
Offer a terse response. 0.09. What is the difference between the highest and the second highest Expenditure(as % of GDP) of Middle East & North Africa (developing only)?
Your answer should be very brief. 0.04. What is the difference between the highest and the second highest Expenditure(as % of GDP) of Paraguay?
Offer a terse response. 0.19. What is the difference between the highest and the lowest Expenditure(as % of GDP) in Latin America(all income levels)?
Ensure brevity in your answer.  0.42. What is the difference between the highest and the lowest Expenditure(as % of GDP) of Latin America(developing only)?
Your answer should be compact. 0.59. What is the difference between the highest and the lowest Expenditure(as % of GDP) of Middle East & North Africa (developing only)?
Ensure brevity in your answer.  1.23. What is the difference between the highest and the lowest Expenditure(as % of GDP) in Paraguay?
Provide a short and direct response. 1.52. 